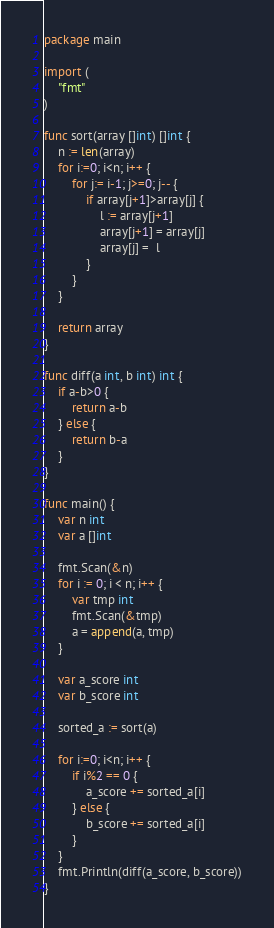<code> <loc_0><loc_0><loc_500><loc_500><_Go_>package main

import (
	"fmt"
)

func sort(array []int) []int {
	n := len(array)
	for i:=0; i<n; i++ {
		for j:= i-1; j>=0; j-- {
			if array[j+1]>array[j] {
				l := array[j+1]
				array[j+1] = array[j]
				array[j] =  l
			}
		}
	}

	return array
}

func diff(a int, b int) int {
	if a-b>0 {
		return a-b
	} else {
		return b-a
	}
}

func main() {
	var n int
	var a []int

	fmt.Scan(&n)
	for i := 0; i < n; i++ {
		var tmp int
		fmt.Scan(&tmp)
		a = append(a, tmp)
	}

	var a_score int
	var b_score int

	sorted_a := sort(a)

	for i:=0; i<n; i++ {
		if i%2 == 0 {
			a_score += sorted_a[i]
		} else {
			b_score += sorted_a[i]
		}
	}
	fmt.Println(diff(a_score, b_score))
}
</code> 